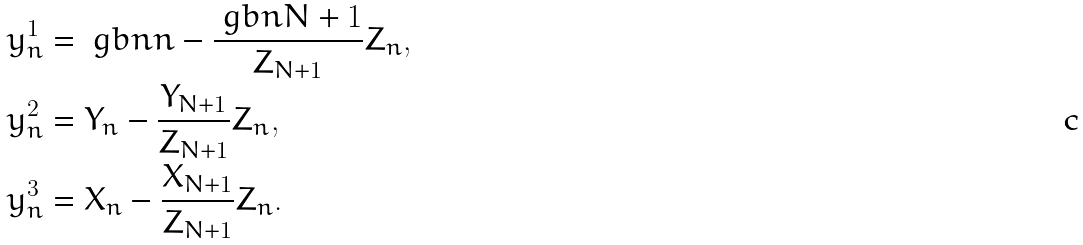<formula> <loc_0><loc_0><loc_500><loc_500>y ^ { 1 } _ { n } & = \ g b n { n } - \frac { \ g b n { N + 1 } } { Z _ { N + 1 } } Z _ { n } , \\ y ^ { 2 } _ { n } & = Y _ { n } - \frac { Y _ { N + 1 } } { Z _ { N + 1 } } Z _ { n } , \\ y ^ { 3 } _ { n } & = X _ { n } - \frac { X _ { N + 1 } } { Z _ { N + 1 } } Z _ { n } .</formula> 